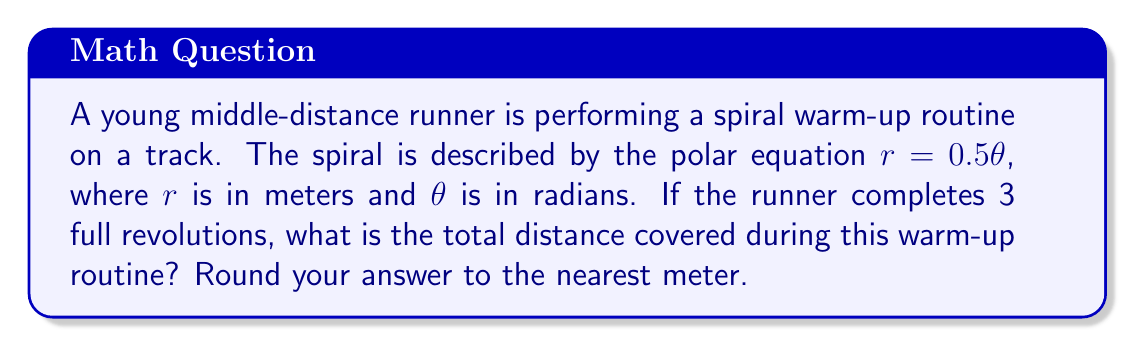Give your solution to this math problem. To solve this problem, we need to use the formula for the arc length of a polar curve. The steps are as follows:

1) The formula for the arc length $L$ of a polar curve from $\theta = a$ to $\theta = b$ is:

   $$L = \int_a^b \sqrt{r^2 + \left(\frac{dr}{d\theta}\right)^2} d\theta$$

2) In our case, $r = 0.5\theta$, so $\frac{dr}{d\theta} = 0.5$

3) Substituting these into the formula:

   $$L = \int_0^{6\pi} \sqrt{(0.5\theta)^2 + (0.5)^2} d\theta$$

4) Simplify under the square root:

   $$L = \int_0^{6\pi} \sqrt{0.25\theta^2 + 0.25} d\theta$$

5) Factor out 0.25:

   $$L = \int_0^{6\pi} 0.5\sqrt{\theta^2 + 1} d\theta$$

6) This integral doesn't have an elementary antiderivative, so we need to use numerical integration. Using a calculator or computer software, we can evaluate this integral:

   $$L \approx 56.55 \text{ meters}$$

7) Rounding to the nearest meter gives us 57 meters.
Answer: 57 meters 